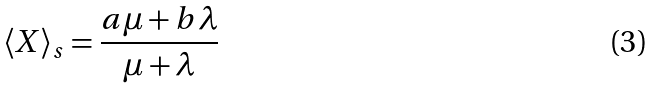<formula> <loc_0><loc_0><loc_500><loc_500>\langle X \rangle _ { s } = \frac { a \mu + b \lambda } { \mu + \lambda }</formula> 